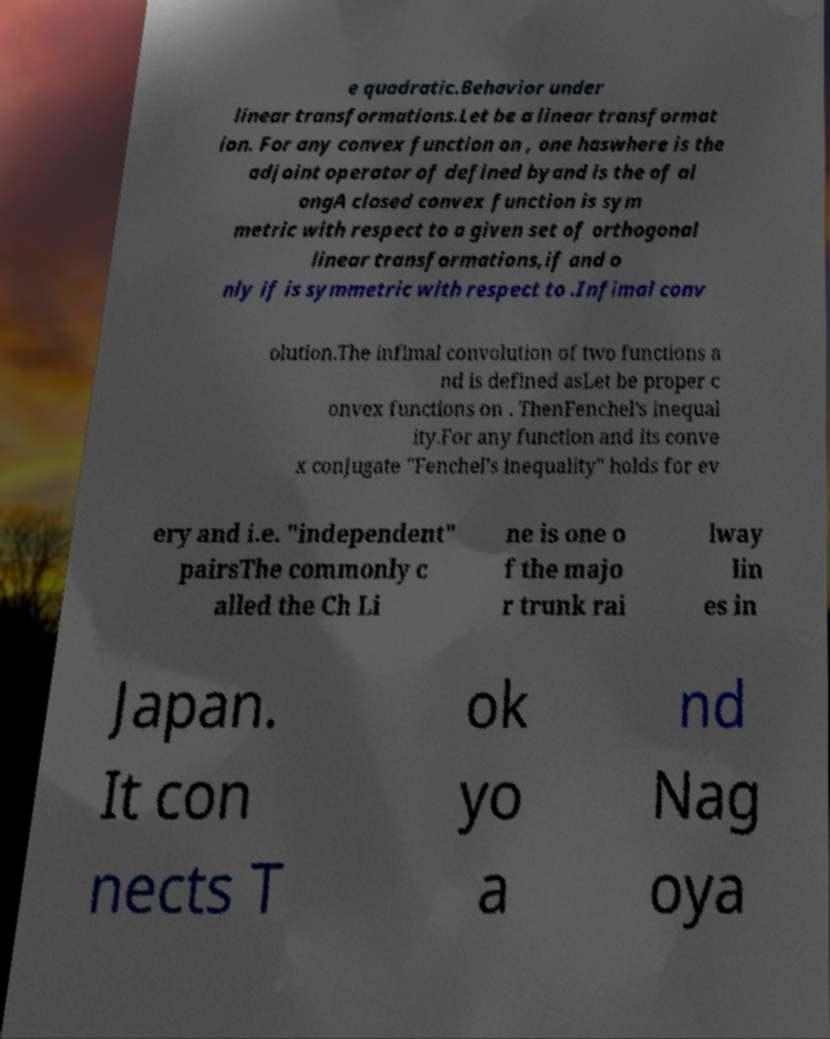There's text embedded in this image that I need extracted. Can you transcribe it verbatim? e quadratic.Behavior under linear transformations.Let be a linear transformat ion. For any convex function on , one haswhere is the adjoint operator of defined byand is the of al ongA closed convex function is sym metric with respect to a given set of orthogonal linear transformations,if and o nly if is symmetric with respect to .Infimal conv olution.The infimal convolution of two functions a nd is defined asLet be proper c onvex functions on . ThenFenchel's inequal ity.For any function and its conve x conjugate "Fenchel's inequality" holds for ev ery and i.e. "independent" pairsThe commonly c alled the Ch Li ne is one o f the majo r trunk rai lway lin es in Japan. It con nects T ok yo a nd Nag oya 